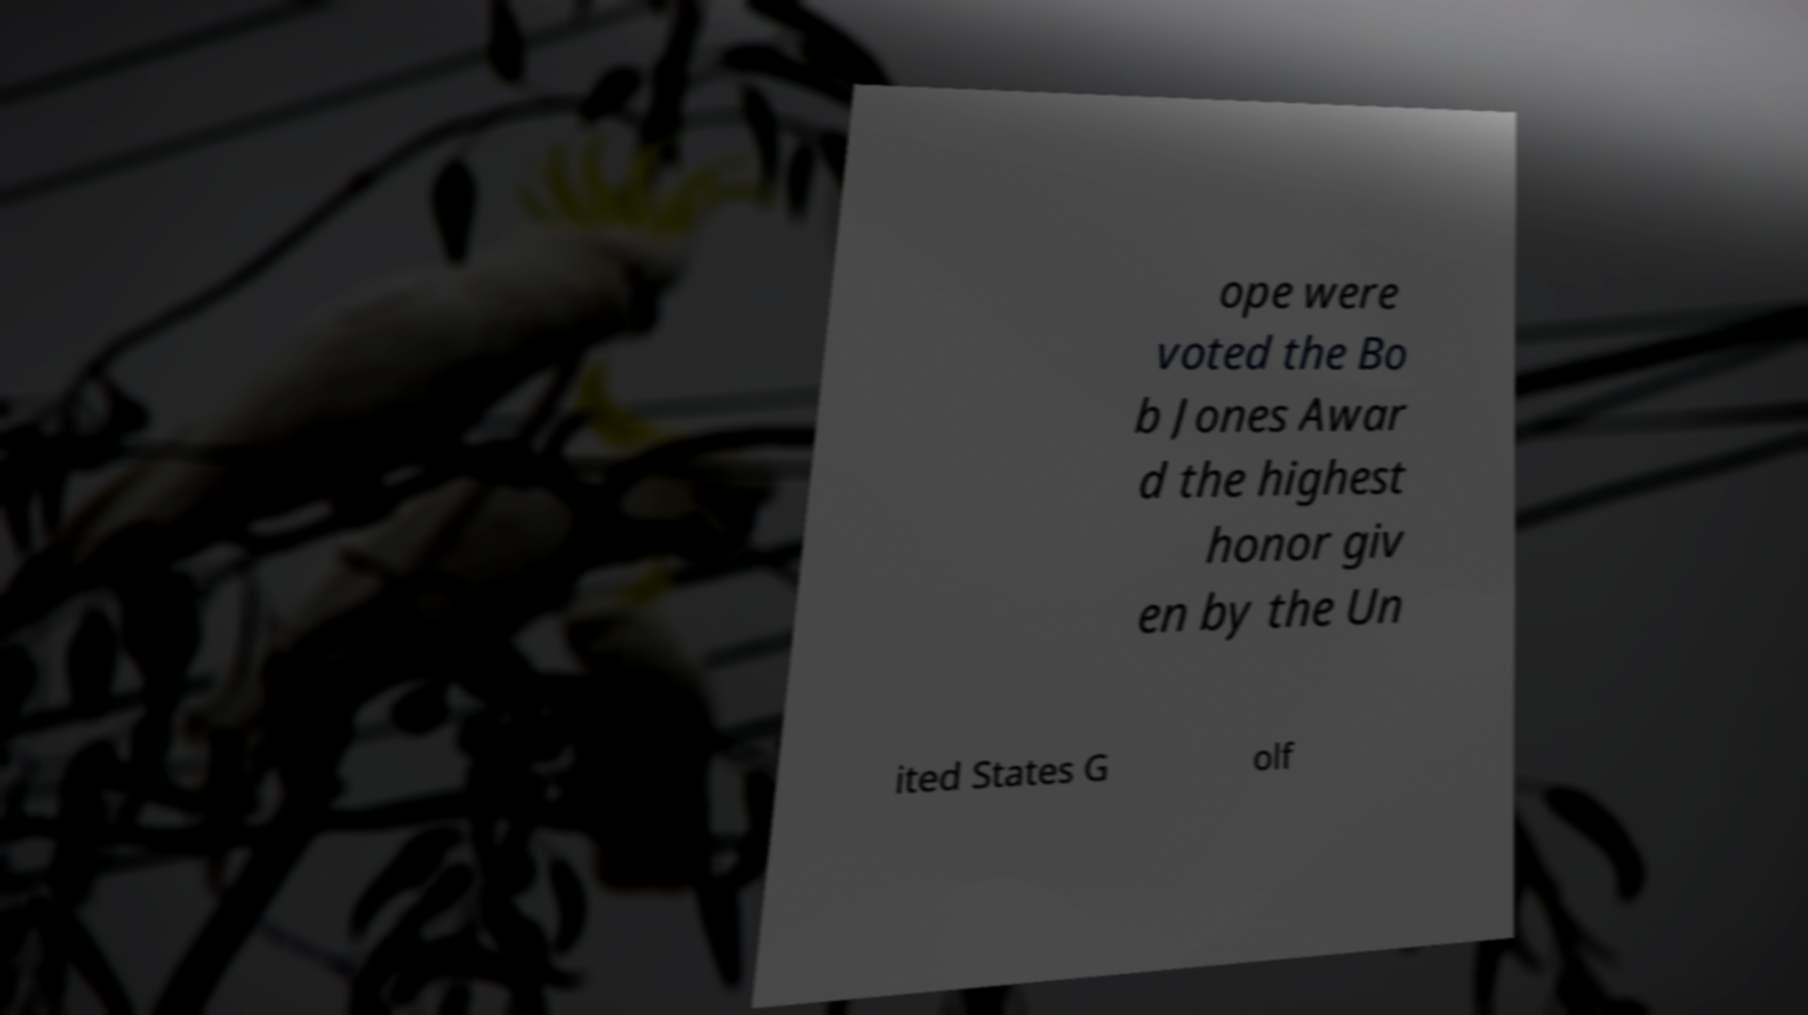Please read and relay the text visible in this image. What does it say? ope were voted the Bo b Jones Awar d the highest honor giv en by the Un ited States G olf 